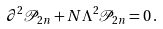Convert formula to latex. <formula><loc_0><loc_0><loc_500><loc_500>\partial ^ { 2 } \mathcal { P } _ { 2 n } + N \Lambda ^ { 2 } \mathcal { P } _ { 2 n } = 0 \, .</formula> 